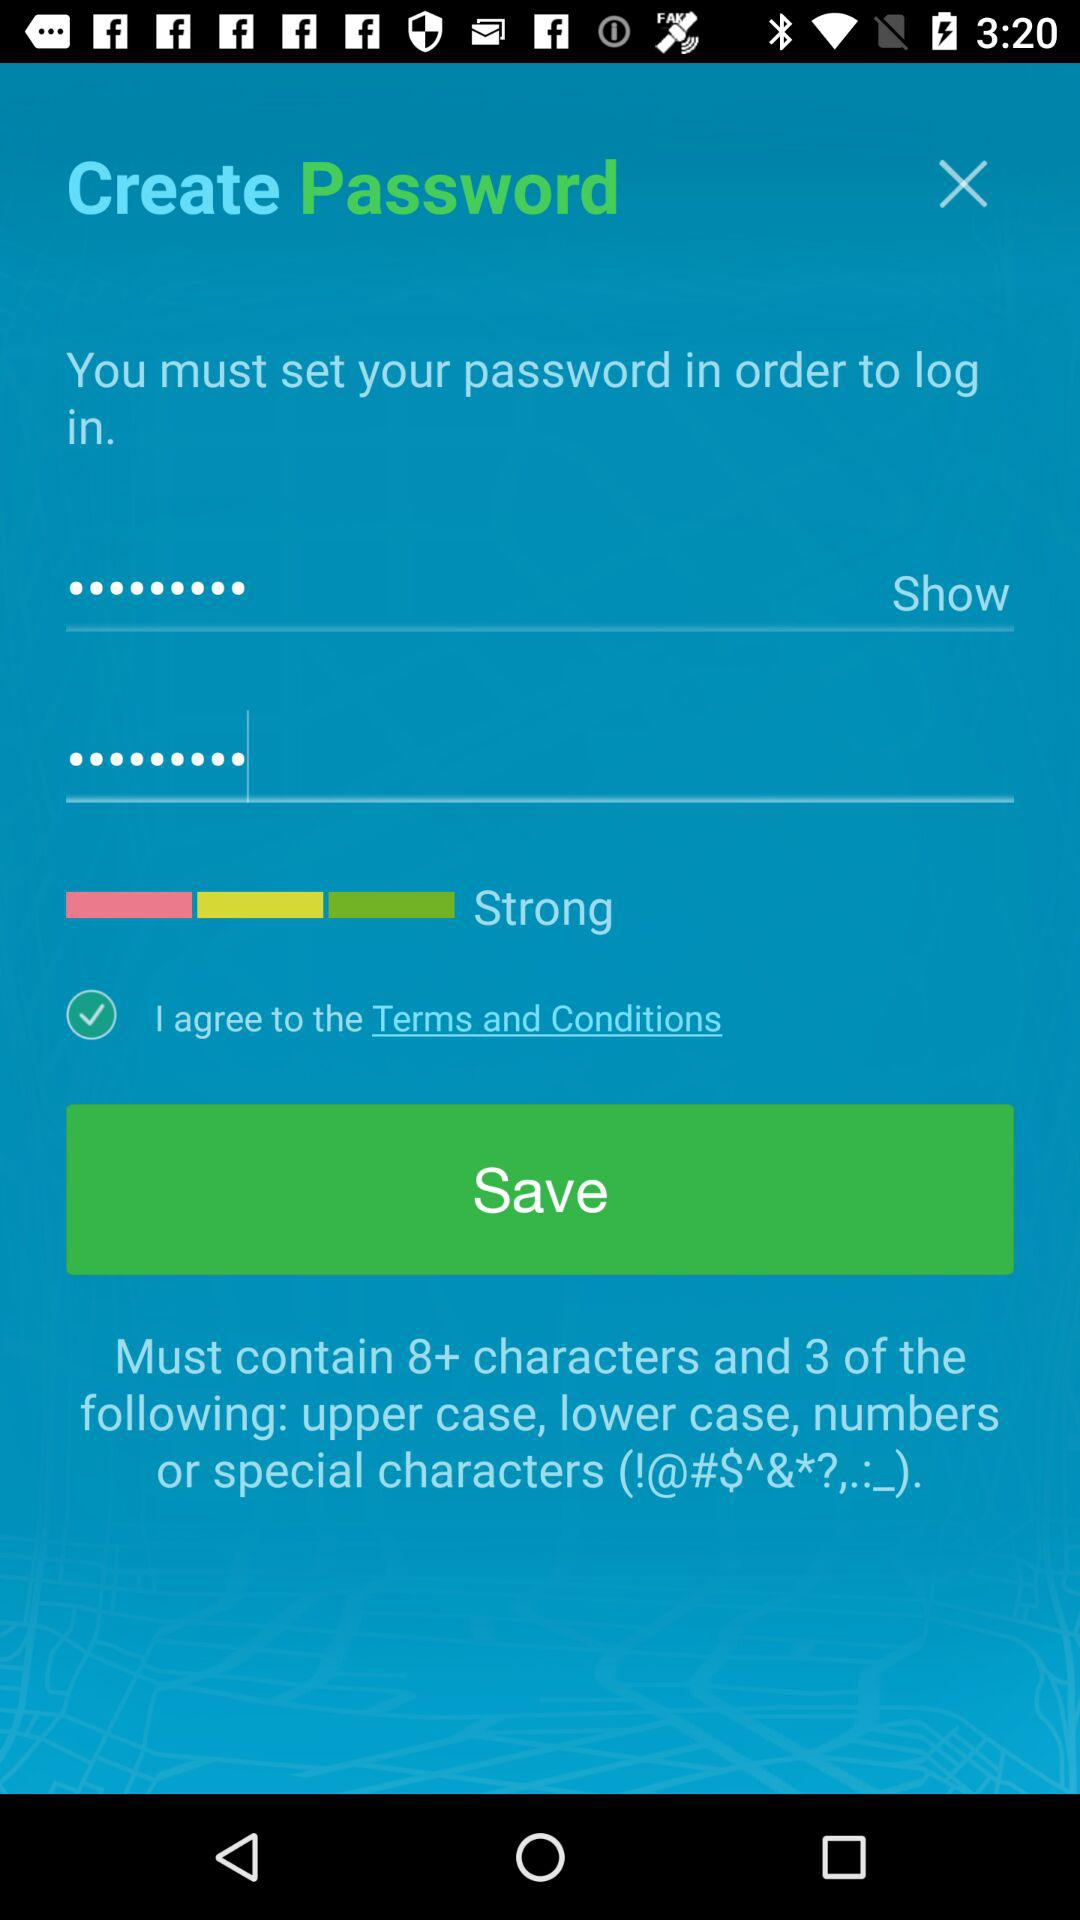What are the criteria to be met for a strong password? The criteria is "Must contain 8+ characters and 3 of the following: upper case, lower case, numbers or special characters (!@#$^&*?,.:_)". 